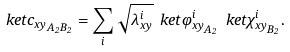Convert formula to latex. <formula><loc_0><loc_0><loc_500><loc_500>\ k e t { c _ { x y } } _ { A _ { 2 } B _ { 2 } } = \sum _ { i } \sqrt { \lambda _ { x y } ^ { i } } \ k e t { \varphi _ { x y } ^ { i } } _ { A _ { 2 } } \ k e t { \chi _ { x y } ^ { i } } _ { B _ { 2 } } .</formula> 